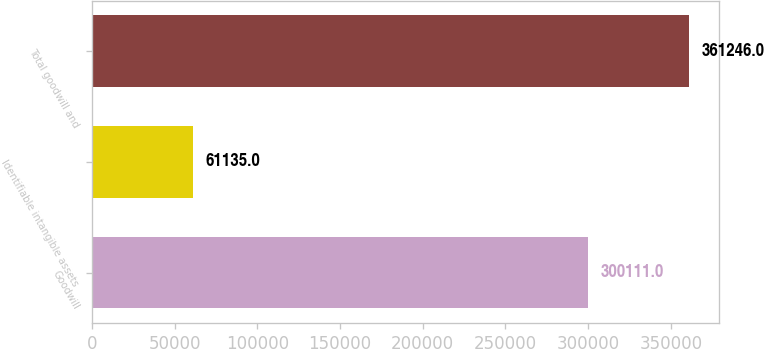<chart> <loc_0><loc_0><loc_500><loc_500><bar_chart><fcel>Goodwill<fcel>Identifiable intangible assets<fcel>Total goodwill and<nl><fcel>300111<fcel>61135<fcel>361246<nl></chart> 